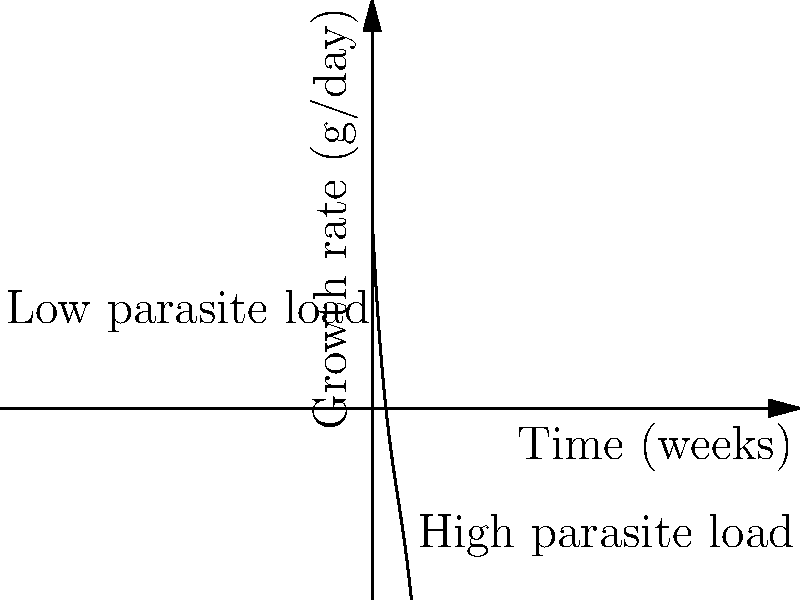The polynomial graph shows the relationship between parasite load and sheep growth rates over time. At which point in time (in weeks) does the growth rate reach its maximum for sheep with a low parasite load? To find the maximum growth rate for sheep with a low parasite load, we need to follow these steps:

1. Observe that the curve for low parasite load reaches its peak earlier than the high parasite load curve.

2. The maximum point on a polynomial curve occurs where its derivative is zero.

3. The general form of this polynomial is:
   $$f(x) = 50 - 20x + 2x^2 - 0.1x^3$$

4. To find the maximum, we need to differentiate this function and set it to zero:
   $$f'(x) = -20 + 4x - 0.3x^2$$

5. Set $f'(x) = 0$:
   $$-20 + 4x - 0.3x^2 = 0$$

6. This is a quadratic equation. Solving it gives us two roots:
   $x \approx 1.95$ and $x \approx 11.38$

7. The smaller root (1.95) corresponds to the maximum for low parasite load, as it occurs earlier in time.

8. Rounding to the nearest week, we get 2 weeks.
Answer: 2 weeks 